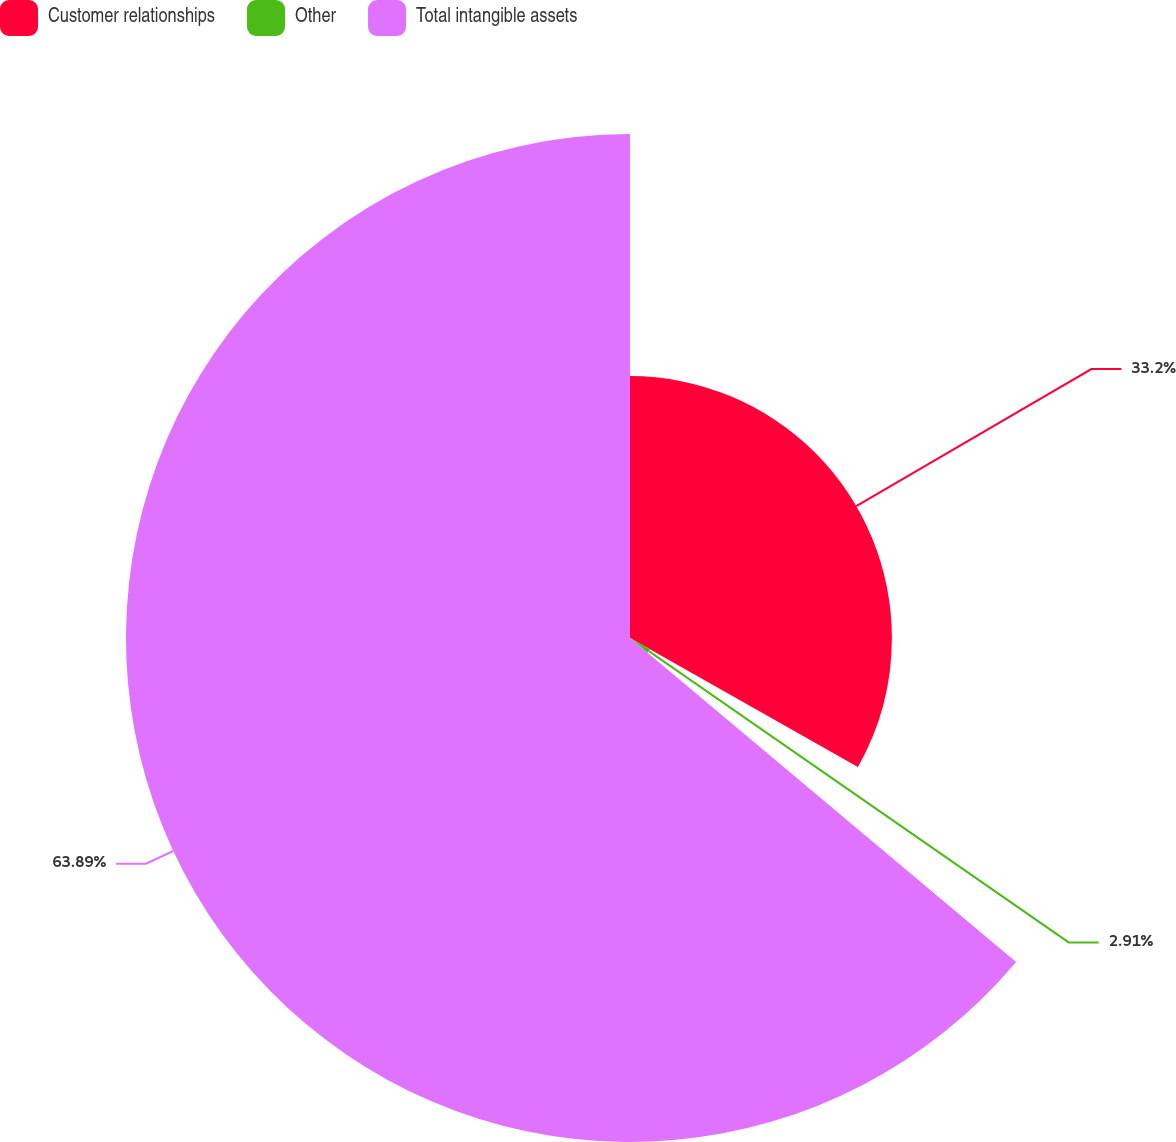Convert chart. <chart><loc_0><loc_0><loc_500><loc_500><pie_chart><fcel>Customer relationships<fcel>Other<fcel>Total intangible assets<nl><fcel>33.2%<fcel>2.91%<fcel>63.89%<nl></chart> 